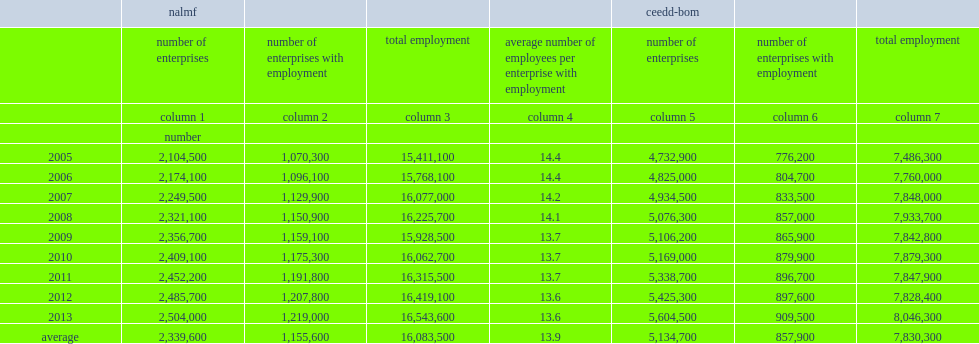From 2005 to 2013, how many enterprises of the nalmf included on average? 2339600.0. What is the number of nalmf are employer enterprises? 1155600.0. How many workers among these employer enterprises employ each year? 16083500.0. What is the number of workers of each enterprise hires on average? 13.9. How many enterprises do the ceedd-bom cover? 5134700.0. About one-sixth of them, or 858,000 enterprises, how many workers employed each year on average? 7830300.0. 